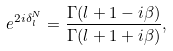Convert formula to latex. <formula><loc_0><loc_0><loc_500><loc_500>e ^ { 2 i \delta _ { l } ^ { N } } = \frac { \Gamma ( l + 1 - i \beta ) } { \Gamma ( l + 1 + i \beta ) } ,</formula> 